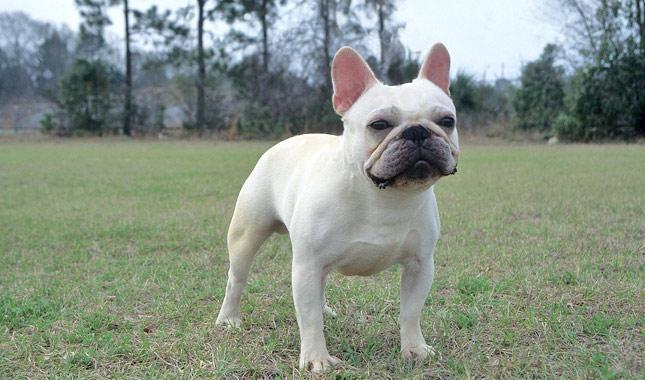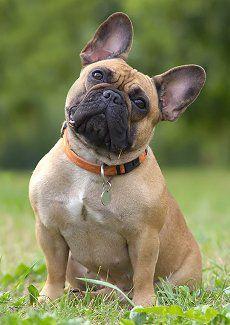The first image is the image on the left, the second image is the image on the right. Considering the images on both sides, is "A dog is wearing a collar." valid? Answer yes or no. Yes. 